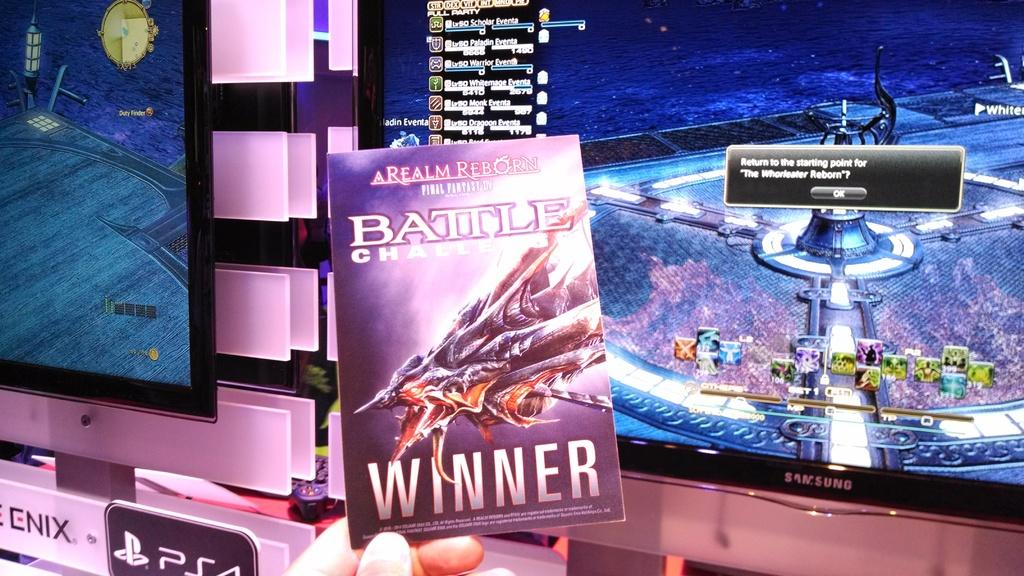<image>
Describe the image concisely. In front of TV screens a person holds a Relam Reborn book. 